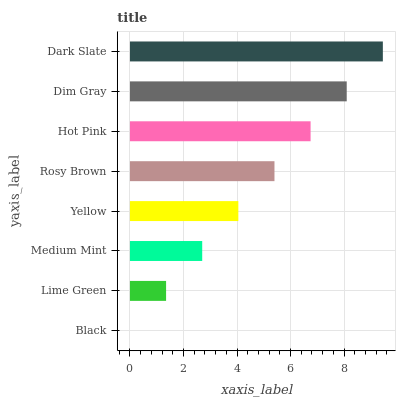Is Black the minimum?
Answer yes or no. Yes. Is Dark Slate the maximum?
Answer yes or no. Yes. Is Lime Green the minimum?
Answer yes or no. No. Is Lime Green the maximum?
Answer yes or no. No. Is Lime Green greater than Black?
Answer yes or no. Yes. Is Black less than Lime Green?
Answer yes or no. Yes. Is Black greater than Lime Green?
Answer yes or no. No. Is Lime Green less than Black?
Answer yes or no. No. Is Rosy Brown the high median?
Answer yes or no. Yes. Is Yellow the low median?
Answer yes or no. Yes. Is Black the high median?
Answer yes or no. No. Is Black the low median?
Answer yes or no. No. 